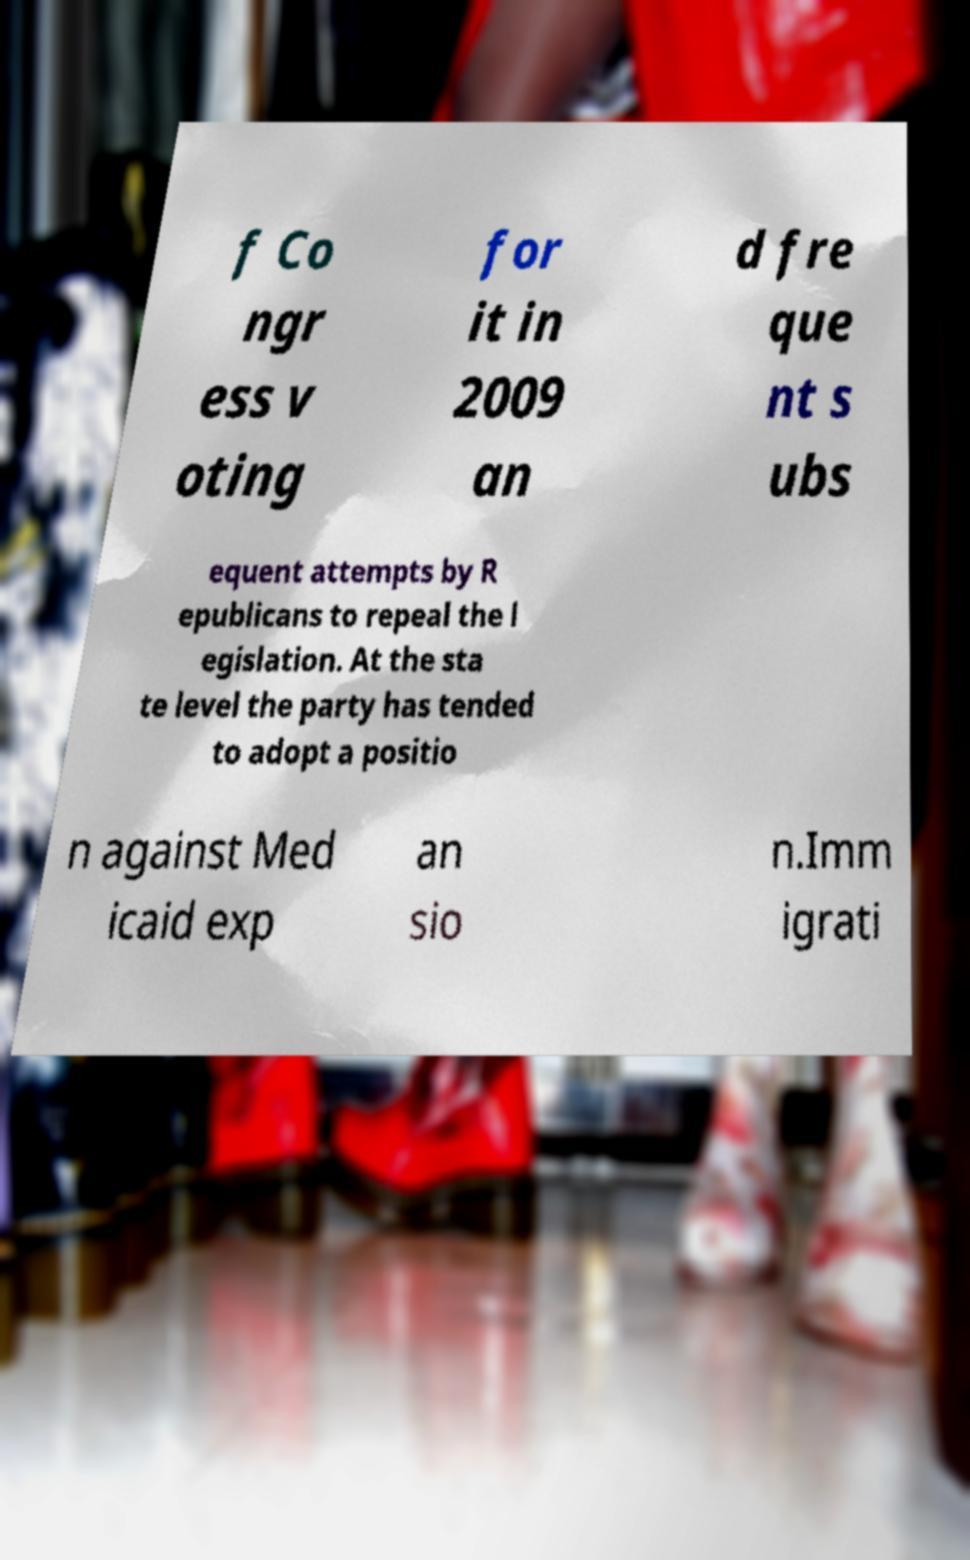What messages or text are displayed in this image? I need them in a readable, typed format. f Co ngr ess v oting for it in 2009 an d fre que nt s ubs equent attempts by R epublicans to repeal the l egislation. At the sta te level the party has tended to adopt a positio n against Med icaid exp an sio n.Imm igrati 